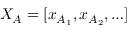<formula> <loc_0><loc_0><loc_500><loc_500>X _ { A } = [ x _ { A _ { 1 } } , x _ { A _ { 2 } } , \dots ]</formula> 